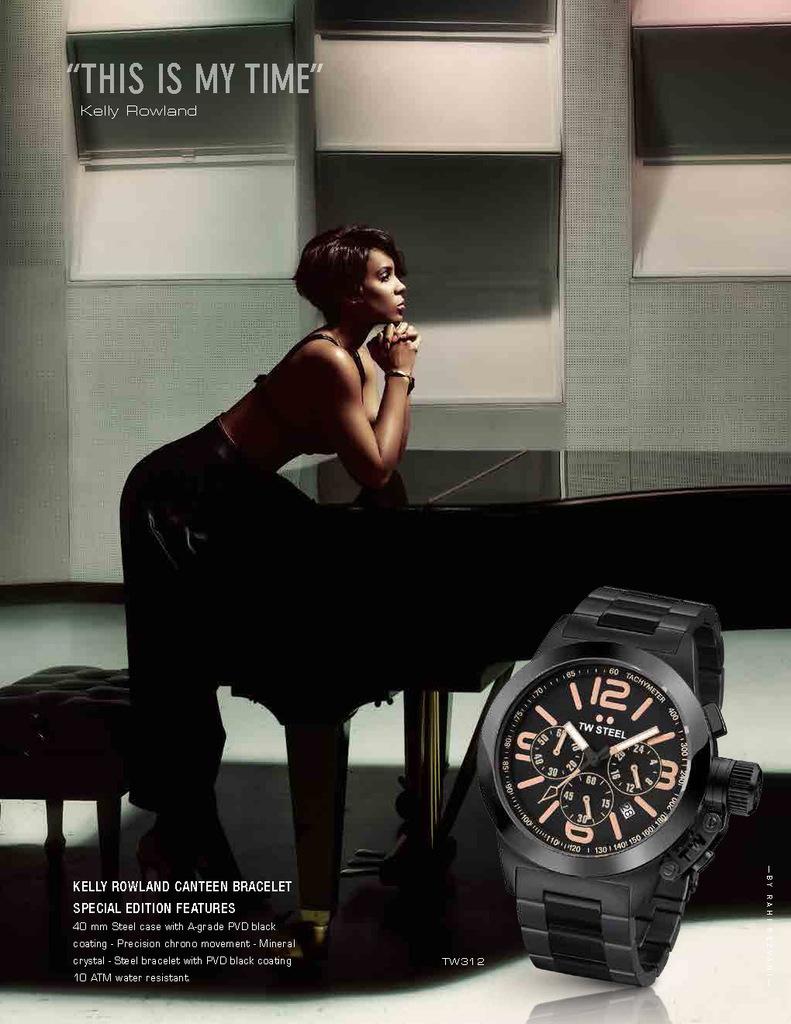What kind of bracelet does this watch have?
Provide a short and direct response. Kelly rowland canteen. What is the name of the person who has a quote in the ad?
Your answer should be very brief. Kelly rowland. 